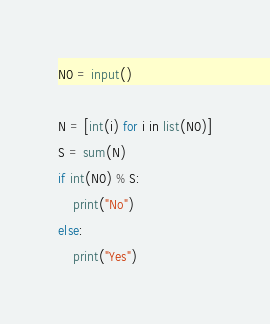Convert code to text. <code><loc_0><loc_0><loc_500><loc_500><_Python_>N0 = input()

N = [int(i) for i in list(N0)]
S = sum(N)
if int(N0) % S:
    print("No")
else:
    print("Yes")</code> 